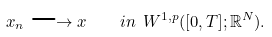Convert formula to latex. <formula><loc_0><loc_0><loc_500><loc_500>x _ { n } \longrightarrow x \quad i n \ W ^ { 1 , p } ( [ 0 , T ] ; \mathbb { R } ^ { N } ) .</formula> 